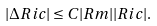Convert formula to latex. <formula><loc_0><loc_0><loc_500><loc_500>| \Delta R i c | \leq C | R m | | R i c | .</formula> 